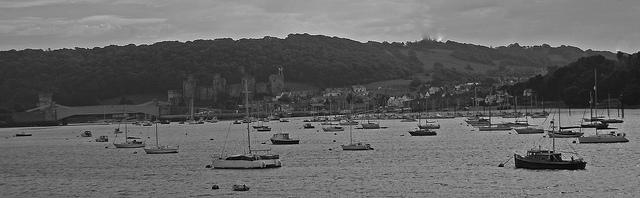Is the landscape flat?
Concise answer only. No. Are the boats anchored?
Quick response, please. Yes. Are these sailing boats?
Quick response, please. Yes. Is there any color in this photo?
Give a very brief answer. No. 